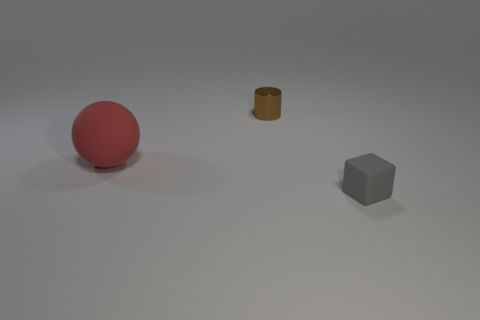Add 1 large gray matte balls. How many objects exist? 4 Subtract all cylinders. How many objects are left? 2 Add 3 gray matte objects. How many gray matte objects exist? 4 Subtract 0 purple blocks. How many objects are left? 3 Subtract all things. Subtract all large brown rubber spheres. How many objects are left? 0 Add 2 rubber objects. How many rubber objects are left? 4 